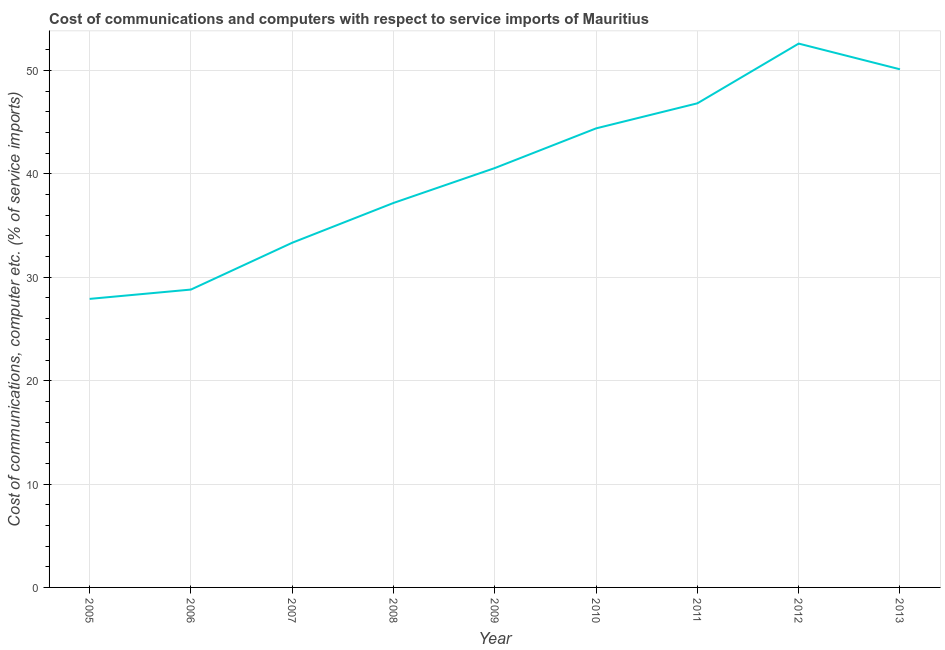What is the cost of communications and computer in 2011?
Ensure brevity in your answer.  46.83. Across all years, what is the maximum cost of communications and computer?
Provide a short and direct response. 52.61. Across all years, what is the minimum cost of communications and computer?
Offer a terse response. 27.91. What is the sum of the cost of communications and computer?
Your response must be concise. 361.82. What is the difference between the cost of communications and computer in 2005 and 2008?
Provide a short and direct response. -9.28. What is the average cost of communications and computer per year?
Ensure brevity in your answer.  40.2. What is the median cost of communications and computer?
Make the answer very short. 40.57. What is the ratio of the cost of communications and computer in 2010 to that in 2012?
Your answer should be compact. 0.84. What is the difference between the highest and the second highest cost of communications and computer?
Your answer should be compact. 2.49. Is the sum of the cost of communications and computer in 2010 and 2012 greater than the maximum cost of communications and computer across all years?
Provide a succinct answer. Yes. What is the difference between the highest and the lowest cost of communications and computer?
Provide a short and direct response. 24.7. In how many years, is the cost of communications and computer greater than the average cost of communications and computer taken over all years?
Your answer should be compact. 5. How many years are there in the graph?
Offer a very short reply. 9. Are the values on the major ticks of Y-axis written in scientific E-notation?
Offer a very short reply. No. What is the title of the graph?
Offer a terse response. Cost of communications and computers with respect to service imports of Mauritius. What is the label or title of the X-axis?
Make the answer very short. Year. What is the label or title of the Y-axis?
Provide a short and direct response. Cost of communications, computer etc. (% of service imports). What is the Cost of communications, computer etc. (% of service imports) of 2005?
Provide a short and direct response. 27.91. What is the Cost of communications, computer etc. (% of service imports) of 2006?
Your answer should be compact. 28.82. What is the Cost of communications, computer etc. (% of service imports) of 2007?
Offer a very short reply. 33.35. What is the Cost of communications, computer etc. (% of service imports) of 2008?
Provide a short and direct response. 37.2. What is the Cost of communications, computer etc. (% of service imports) of 2009?
Provide a short and direct response. 40.57. What is the Cost of communications, computer etc. (% of service imports) in 2010?
Make the answer very short. 44.41. What is the Cost of communications, computer etc. (% of service imports) of 2011?
Give a very brief answer. 46.83. What is the Cost of communications, computer etc. (% of service imports) in 2012?
Offer a terse response. 52.61. What is the Cost of communications, computer etc. (% of service imports) in 2013?
Your answer should be very brief. 50.12. What is the difference between the Cost of communications, computer etc. (% of service imports) in 2005 and 2006?
Your answer should be very brief. -0.9. What is the difference between the Cost of communications, computer etc. (% of service imports) in 2005 and 2007?
Provide a short and direct response. -5.43. What is the difference between the Cost of communications, computer etc. (% of service imports) in 2005 and 2008?
Provide a succinct answer. -9.28. What is the difference between the Cost of communications, computer etc. (% of service imports) in 2005 and 2009?
Provide a succinct answer. -12.66. What is the difference between the Cost of communications, computer etc. (% of service imports) in 2005 and 2010?
Provide a short and direct response. -16.5. What is the difference between the Cost of communications, computer etc. (% of service imports) in 2005 and 2011?
Give a very brief answer. -18.92. What is the difference between the Cost of communications, computer etc. (% of service imports) in 2005 and 2012?
Offer a very short reply. -24.7. What is the difference between the Cost of communications, computer etc. (% of service imports) in 2005 and 2013?
Provide a succinct answer. -22.21. What is the difference between the Cost of communications, computer etc. (% of service imports) in 2006 and 2007?
Make the answer very short. -4.53. What is the difference between the Cost of communications, computer etc. (% of service imports) in 2006 and 2008?
Provide a short and direct response. -8.38. What is the difference between the Cost of communications, computer etc. (% of service imports) in 2006 and 2009?
Ensure brevity in your answer.  -11.76. What is the difference between the Cost of communications, computer etc. (% of service imports) in 2006 and 2010?
Offer a very short reply. -15.59. What is the difference between the Cost of communications, computer etc. (% of service imports) in 2006 and 2011?
Your answer should be compact. -18.02. What is the difference between the Cost of communications, computer etc. (% of service imports) in 2006 and 2012?
Your answer should be compact. -23.8. What is the difference between the Cost of communications, computer etc. (% of service imports) in 2006 and 2013?
Provide a succinct answer. -21.31. What is the difference between the Cost of communications, computer etc. (% of service imports) in 2007 and 2008?
Give a very brief answer. -3.85. What is the difference between the Cost of communications, computer etc. (% of service imports) in 2007 and 2009?
Ensure brevity in your answer.  -7.23. What is the difference between the Cost of communications, computer etc. (% of service imports) in 2007 and 2010?
Offer a terse response. -11.06. What is the difference between the Cost of communications, computer etc. (% of service imports) in 2007 and 2011?
Offer a very short reply. -13.49. What is the difference between the Cost of communications, computer etc. (% of service imports) in 2007 and 2012?
Keep it short and to the point. -19.27. What is the difference between the Cost of communications, computer etc. (% of service imports) in 2007 and 2013?
Your response must be concise. -16.78. What is the difference between the Cost of communications, computer etc. (% of service imports) in 2008 and 2009?
Offer a terse response. -3.38. What is the difference between the Cost of communications, computer etc. (% of service imports) in 2008 and 2010?
Give a very brief answer. -7.21. What is the difference between the Cost of communications, computer etc. (% of service imports) in 2008 and 2011?
Offer a very short reply. -9.64. What is the difference between the Cost of communications, computer etc. (% of service imports) in 2008 and 2012?
Your answer should be very brief. -15.42. What is the difference between the Cost of communications, computer etc. (% of service imports) in 2008 and 2013?
Your answer should be compact. -12.93. What is the difference between the Cost of communications, computer etc. (% of service imports) in 2009 and 2010?
Offer a very short reply. -3.84. What is the difference between the Cost of communications, computer etc. (% of service imports) in 2009 and 2011?
Your answer should be very brief. -6.26. What is the difference between the Cost of communications, computer etc. (% of service imports) in 2009 and 2012?
Make the answer very short. -12.04. What is the difference between the Cost of communications, computer etc. (% of service imports) in 2009 and 2013?
Keep it short and to the point. -9.55. What is the difference between the Cost of communications, computer etc. (% of service imports) in 2010 and 2011?
Provide a short and direct response. -2.42. What is the difference between the Cost of communications, computer etc. (% of service imports) in 2010 and 2012?
Make the answer very short. -8.2. What is the difference between the Cost of communications, computer etc. (% of service imports) in 2010 and 2013?
Ensure brevity in your answer.  -5.71. What is the difference between the Cost of communications, computer etc. (% of service imports) in 2011 and 2012?
Offer a terse response. -5.78. What is the difference between the Cost of communications, computer etc. (% of service imports) in 2011 and 2013?
Your response must be concise. -3.29. What is the difference between the Cost of communications, computer etc. (% of service imports) in 2012 and 2013?
Offer a very short reply. 2.49. What is the ratio of the Cost of communications, computer etc. (% of service imports) in 2005 to that in 2006?
Provide a succinct answer. 0.97. What is the ratio of the Cost of communications, computer etc. (% of service imports) in 2005 to that in 2007?
Provide a short and direct response. 0.84. What is the ratio of the Cost of communications, computer etc. (% of service imports) in 2005 to that in 2009?
Give a very brief answer. 0.69. What is the ratio of the Cost of communications, computer etc. (% of service imports) in 2005 to that in 2010?
Your response must be concise. 0.63. What is the ratio of the Cost of communications, computer etc. (% of service imports) in 2005 to that in 2011?
Provide a short and direct response. 0.6. What is the ratio of the Cost of communications, computer etc. (% of service imports) in 2005 to that in 2012?
Ensure brevity in your answer.  0.53. What is the ratio of the Cost of communications, computer etc. (% of service imports) in 2005 to that in 2013?
Your response must be concise. 0.56. What is the ratio of the Cost of communications, computer etc. (% of service imports) in 2006 to that in 2007?
Your response must be concise. 0.86. What is the ratio of the Cost of communications, computer etc. (% of service imports) in 2006 to that in 2008?
Offer a very short reply. 0.78. What is the ratio of the Cost of communications, computer etc. (% of service imports) in 2006 to that in 2009?
Provide a succinct answer. 0.71. What is the ratio of the Cost of communications, computer etc. (% of service imports) in 2006 to that in 2010?
Ensure brevity in your answer.  0.65. What is the ratio of the Cost of communications, computer etc. (% of service imports) in 2006 to that in 2011?
Your answer should be very brief. 0.61. What is the ratio of the Cost of communications, computer etc. (% of service imports) in 2006 to that in 2012?
Give a very brief answer. 0.55. What is the ratio of the Cost of communications, computer etc. (% of service imports) in 2006 to that in 2013?
Keep it short and to the point. 0.57. What is the ratio of the Cost of communications, computer etc. (% of service imports) in 2007 to that in 2008?
Ensure brevity in your answer.  0.9. What is the ratio of the Cost of communications, computer etc. (% of service imports) in 2007 to that in 2009?
Ensure brevity in your answer.  0.82. What is the ratio of the Cost of communications, computer etc. (% of service imports) in 2007 to that in 2010?
Keep it short and to the point. 0.75. What is the ratio of the Cost of communications, computer etc. (% of service imports) in 2007 to that in 2011?
Ensure brevity in your answer.  0.71. What is the ratio of the Cost of communications, computer etc. (% of service imports) in 2007 to that in 2012?
Offer a very short reply. 0.63. What is the ratio of the Cost of communications, computer etc. (% of service imports) in 2007 to that in 2013?
Provide a short and direct response. 0.67. What is the ratio of the Cost of communications, computer etc. (% of service imports) in 2008 to that in 2009?
Your response must be concise. 0.92. What is the ratio of the Cost of communications, computer etc. (% of service imports) in 2008 to that in 2010?
Provide a succinct answer. 0.84. What is the ratio of the Cost of communications, computer etc. (% of service imports) in 2008 to that in 2011?
Your response must be concise. 0.79. What is the ratio of the Cost of communications, computer etc. (% of service imports) in 2008 to that in 2012?
Make the answer very short. 0.71. What is the ratio of the Cost of communications, computer etc. (% of service imports) in 2008 to that in 2013?
Give a very brief answer. 0.74. What is the ratio of the Cost of communications, computer etc. (% of service imports) in 2009 to that in 2010?
Provide a succinct answer. 0.91. What is the ratio of the Cost of communications, computer etc. (% of service imports) in 2009 to that in 2011?
Your answer should be very brief. 0.87. What is the ratio of the Cost of communications, computer etc. (% of service imports) in 2009 to that in 2012?
Make the answer very short. 0.77. What is the ratio of the Cost of communications, computer etc. (% of service imports) in 2009 to that in 2013?
Your response must be concise. 0.81. What is the ratio of the Cost of communications, computer etc. (% of service imports) in 2010 to that in 2011?
Offer a terse response. 0.95. What is the ratio of the Cost of communications, computer etc. (% of service imports) in 2010 to that in 2012?
Provide a short and direct response. 0.84. What is the ratio of the Cost of communications, computer etc. (% of service imports) in 2010 to that in 2013?
Your answer should be very brief. 0.89. What is the ratio of the Cost of communications, computer etc. (% of service imports) in 2011 to that in 2012?
Offer a very short reply. 0.89. What is the ratio of the Cost of communications, computer etc. (% of service imports) in 2011 to that in 2013?
Keep it short and to the point. 0.93. 